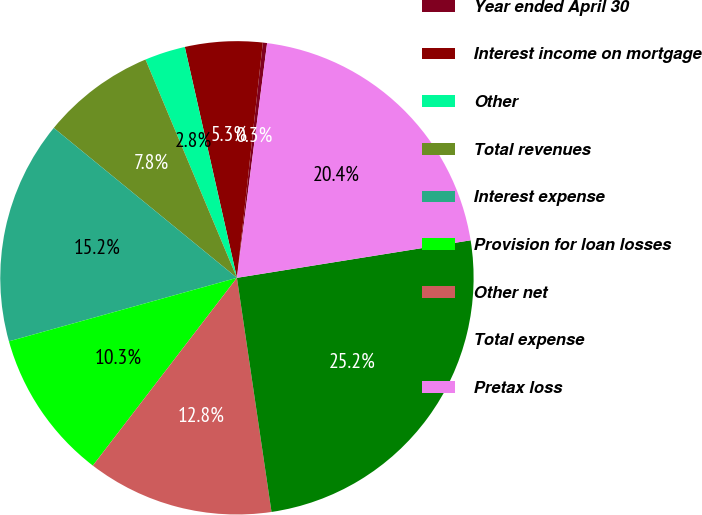<chart> <loc_0><loc_0><loc_500><loc_500><pie_chart><fcel>Year ended April 30<fcel>Interest income on mortgage<fcel>Other<fcel>Total revenues<fcel>Interest expense<fcel>Provision for loan losses<fcel>Other net<fcel>Total expense<fcel>Pretax loss<nl><fcel>0.29%<fcel>5.28%<fcel>2.78%<fcel>7.77%<fcel>15.24%<fcel>10.26%<fcel>12.75%<fcel>25.2%<fcel>20.43%<nl></chart> 